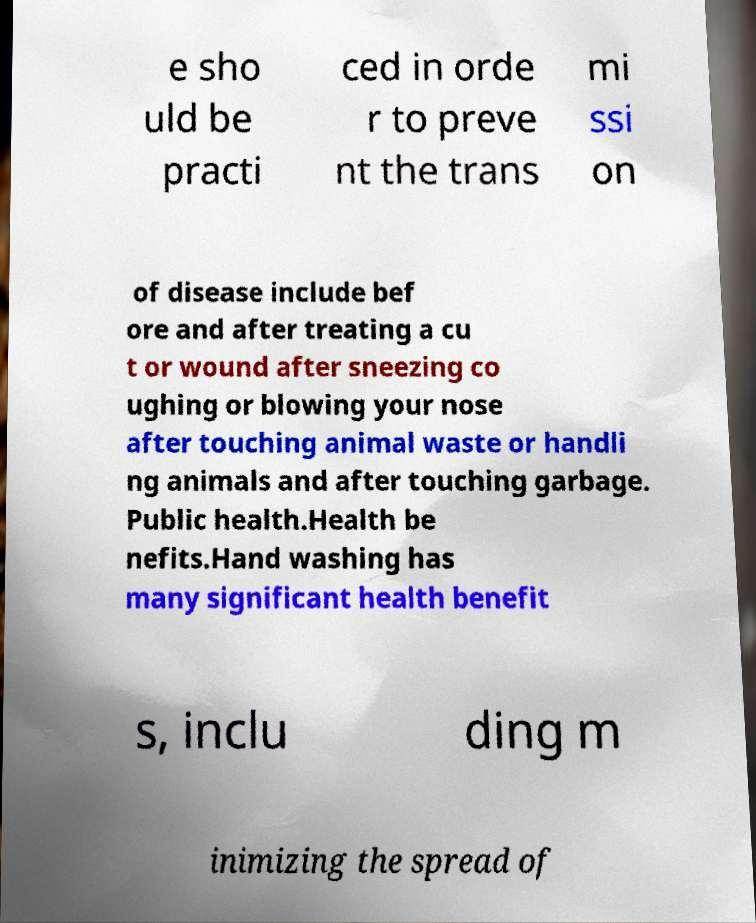There's text embedded in this image that I need extracted. Can you transcribe it verbatim? e sho uld be practi ced in orde r to preve nt the trans mi ssi on of disease include bef ore and after treating a cu t or wound after sneezing co ughing or blowing your nose after touching animal waste or handli ng animals and after touching garbage. Public health.Health be nefits.Hand washing has many significant health benefit s, inclu ding m inimizing the spread of 